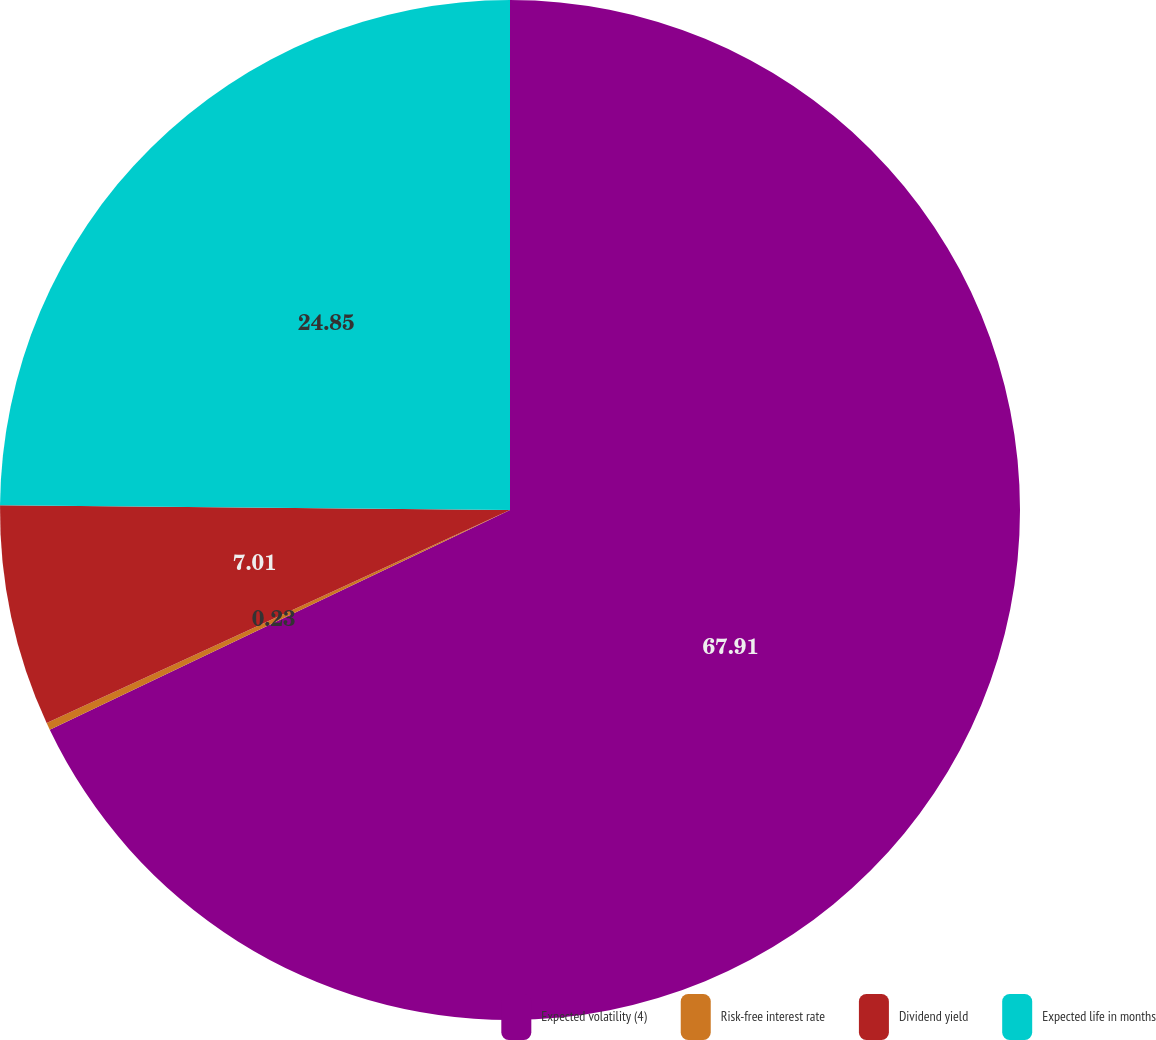Convert chart to OTSL. <chart><loc_0><loc_0><loc_500><loc_500><pie_chart><fcel>Expected volatility (4)<fcel>Risk-free interest rate<fcel>Dividend yield<fcel>Expected life in months<nl><fcel>67.91%<fcel>0.23%<fcel>7.01%<fcel>24.85%<nl></chart> 